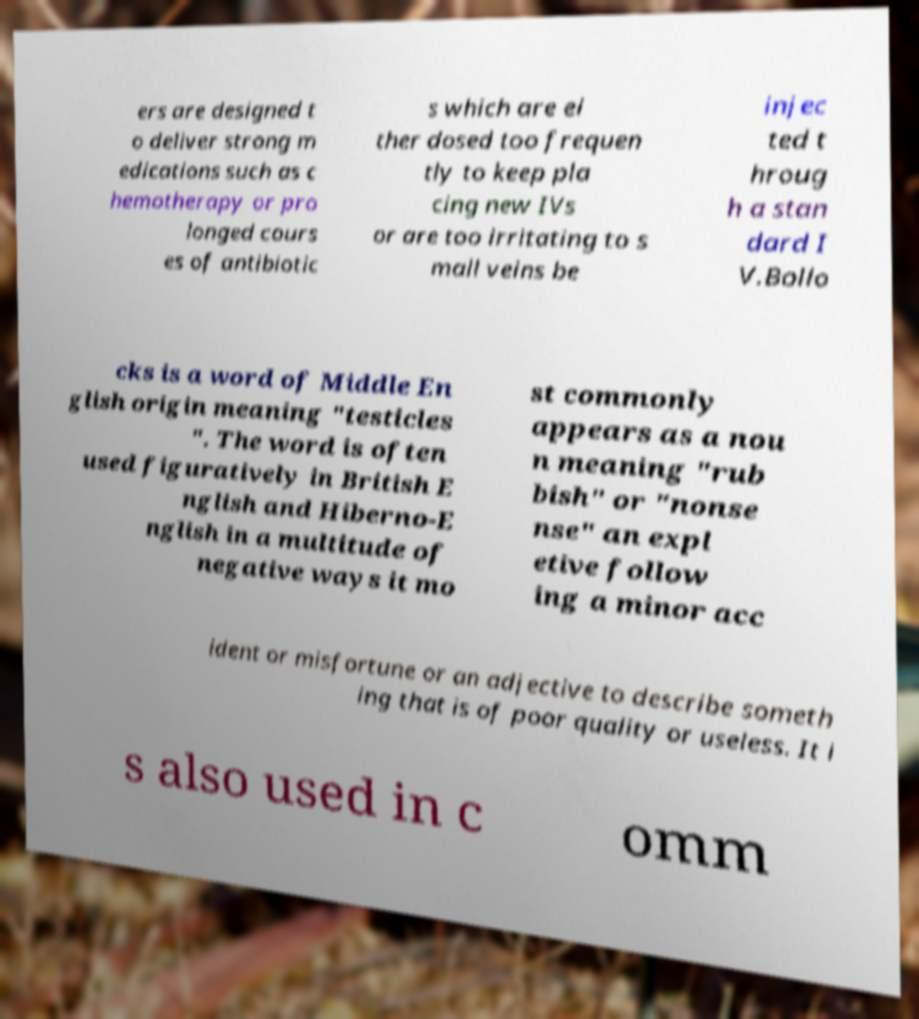Can you accurately transcribe the text from the provided image for me? ers are designed t o deliver strong m edications such as c hemotherapy or pro longed cours es of antibiotic s which are ei ther dosed too frequen tly to keep pla cing new IVs or are too irritating to s mall veins be injec ted t hroug h a stan dard I V.Bollo cks is a word of Middle En glish origin meaning "testicles ". The word is often used figuratively in British E nglish and Hiberno-E nglish in a multitude of negative ways it mo st commonly appears as a nou n meaning "rub bish" or "nonse nse" an expl etive follow ing a minor acc ident or misfortune or an adjective to describe someth ing that is of poor quality or useless. It i s also used in c omm 